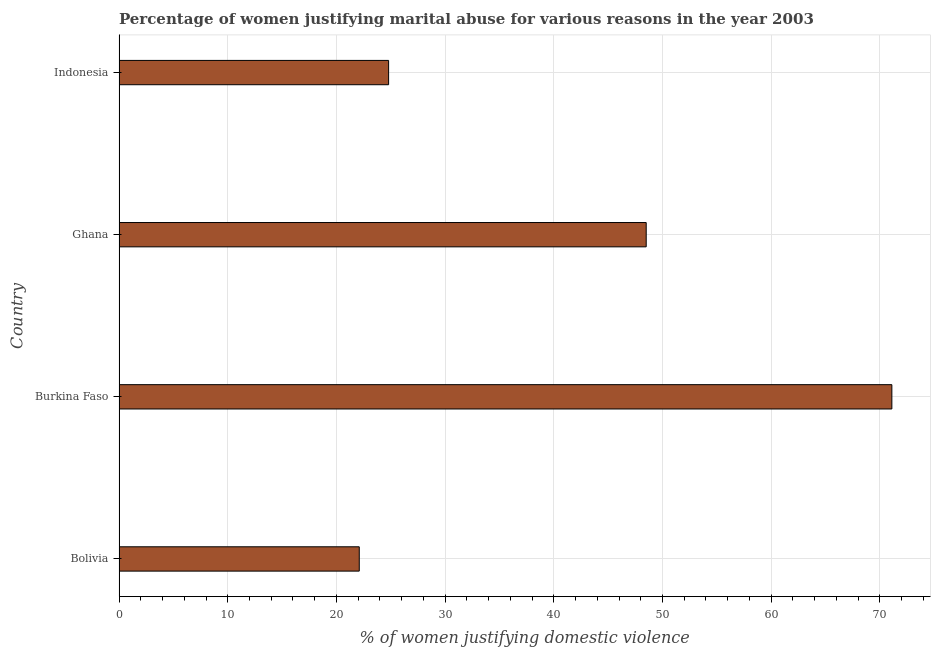What is the title of the graph?
Ensure brevity in your answer.  Percentage of women justifying marital abuse for various reasons in the year 2003. What is the label or title of the X-axis?
Provide a short and direct response. % of women justifying domestic violence. What is the label or title of the Y-axis?
Give a very brief answer. Country. What is the percentage of women justifying marital abuse in Burkina Faso?
Make the answer very short. 71.1. Across all countries, what is the maximum percentage of women justifying marital abuse?
Your response must be concise. 71.1. Across all countries, what is the minimum percentage of women justifying marital abuse?
Your response must be concise. 22.1. In which country was the percentage of women justifying marital abuse maximum?
Offer a terse response. Burkina Faso. In which country was the percentage of women justifying marital abuse minimum?
Make the answer very short. Bolivia. What is the sum of the percentage of women justifying marital abuse?
Give a very brief answer. 166.5. What is the difference between the percentage of women justifying marital abuse in Burkina Faso and Ghana?
Offer a very short reply. 22.6. What is the average percentage of women justifying marital abuse per country?
Your answer should be very brief. 41.62. What is the median percentage of women justifying marital abuse?
Keep it short and to the point. 36.65. What is the ratio of the percentage of women justifying marital abuse in Burkina Faso to that in Ghana?
Give a very brief answer. 1.47. Is the percentage of women justifying marital abuse in Burkina Faso less than that in Ghana?
Your response must be concise. No. What is the difference between the highest and the second highest percentage of women justifying marital abuse?
Give a very brief answer. 22.6. Is the sum of the percentage of women justifying marital abuse in Ghana and Indonesia greater than the maximum percentage of women justifying marital abuse across all countries?
Keep it short and to the point. Yes. How many bars are there?
Offer a terse response. 4. What is the % of women justifying domestic violence of Bolivia?
Provide a succinct answer. 22.1. What is the % of women justifying domestic violence in Burkina Faso?
Provide a succinct answer. 71.1. What is the % of women justifying domestic violence of Ghana?
Provide a short and direct response. 48.5. What is the % of women justifying domestic violence of Indonesia?
Offer a very short reply. 24.8. What is the difference between the % of women justifying domestic violence in Bolivia and Burkina Faso?
Make the answer very short. -49. What is the difference between the % of women justifying domestic violence in Bolivia and Ghana?
Provide a short and direct response. -26.4. What is the difference between the % of women justifying domestic violence in Burkina Faso and Ghana?
Your answer should be very brief. 22.6. What is the difference between the % of women justifying domestic violence in Burkina Faso and Indonesia?
Ensure brevity in your answer.  46.3. What is the difference between the % of women justifying domestic violence in Ghana and Indonesia?
Provide a short and direct response. 23.7. What is the ratio of the % of women justifying domestic violence in Bolivia to that in Burkina Faso?
Provide a short and direct response. 0.31. What is the ratio of the % of women justifying domestic violence in Bolivia to that in Ghana?
Ensure brevity in your answer.  0.46. What is the ratio of the % of women justifying domestic violence in Bolivia to that in Indonesia?
Your response must be concise. 0.89. What is the ratio of the % of women justifying domestic violence in Burkina Faso to that in Ghana?
Ensure brevity in your answer.  1.47. What is the ratio of the % of women justifying domestic violence in Burkina Faso to that in Indonesia?
Your response must be concise. 2.87. What is the ratio of the % of women justifying domestic violence in Ghana to that in Indonesia?
Your response must be concise. 1.96. 